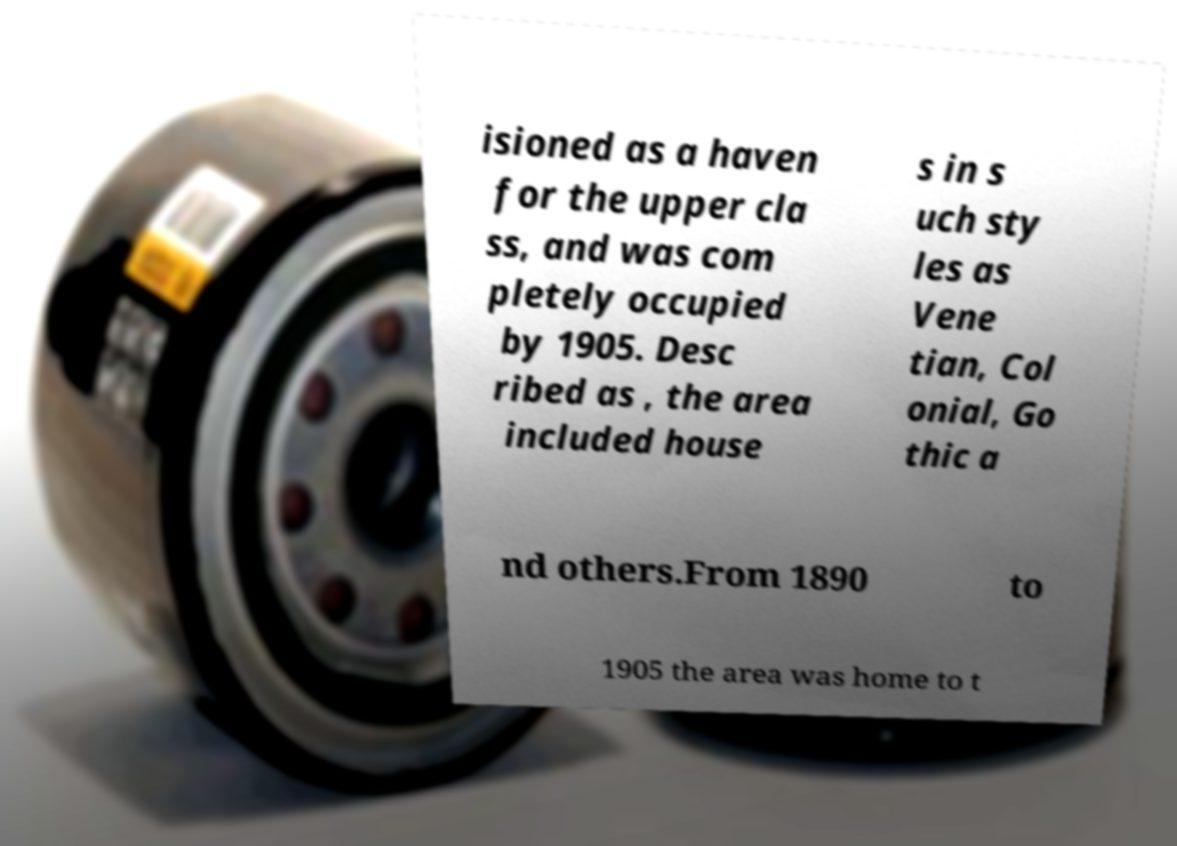Can you accurately transcribe the text from the provided image for me? isioned as a haven for the upper cla ss, and was com pletely occupied by 1905. Desc ribed as , the area included house s in s uch sty les as Vene tian, Col onial, Go thic a nd others.From 1890 to 1905 the area was home to t 